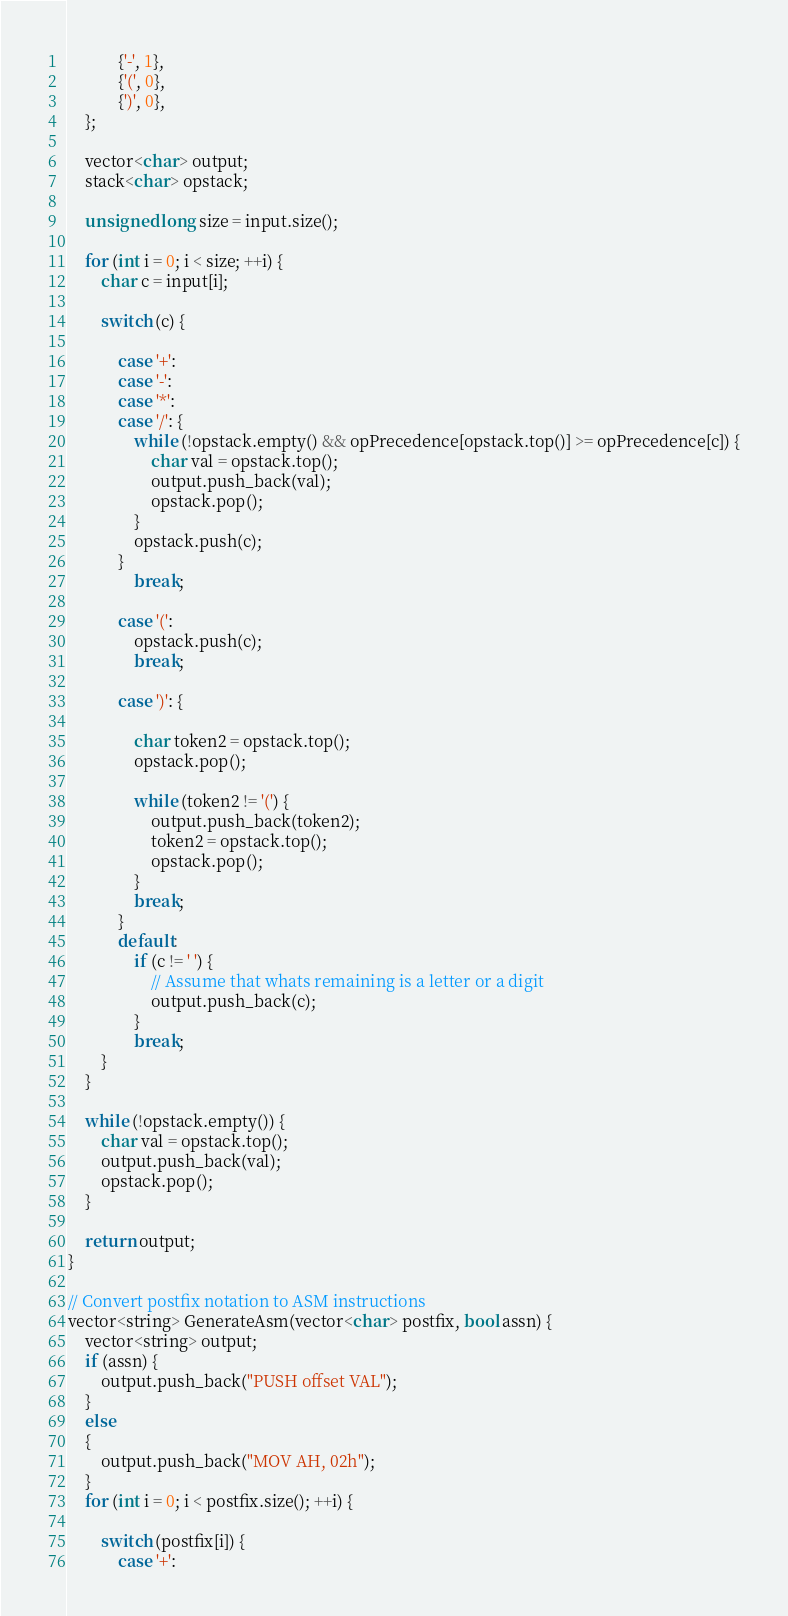<code> <loc_0><loc_0><loc_500><loc_500><_C++_>            {'-', 1},
            {'(', 0},
            {')', 0},
    };

    vector<char> output;
    stack<char> opstack;

    unsigned long size = input.size();

    for (int i = 0; i < size; ++i) {
        char c = input[i];

        switch (c) {

            case '+':
            case '-':
            case '*':
            case '/': {
                while (!opstack.empty() && opPrecedence[opstack.top()] >= opPrecedence[c]) {
                    char val = opstack.top();
                    output.push_back(val);
                    opstack.pop();
                }
                opstack.push(c);
            }
                break;

            case '(':
                opstack.push(c);
                break;

            case ')': {

                char token2 = opstack.top();
                opstack.pop();

                while (token2 != '(') {
                    output.push_back(token2);
                    token2 = opstack.top();
                    opstack.pop();
                }
                break;
            }
            default:
                if (c != ' ') {
                    // Assume that whats remaining is a letter or a digit
                    output.push_back(c);
                }
                break;
        }
    }

    while (!opstack.empty()) {
        char val = opstack.top();
        output.push_back(val);
        opstack.pop();
    }

    return output;
}

// Convert postfix notation to ASM instructions
vector<string> GenerateAsm(vector<char> postfix, bool assn) {
    vector<string> output;
    if (assn) {
        output.push_back("PUSH offset VAL");
    }
    else
    {
        output.push_back("MOV AH, 02h");
    }
    for (int i = 0; i < postfix.size(); ++i) {

        switch (postfix[i]) {
            case '+':</code> 